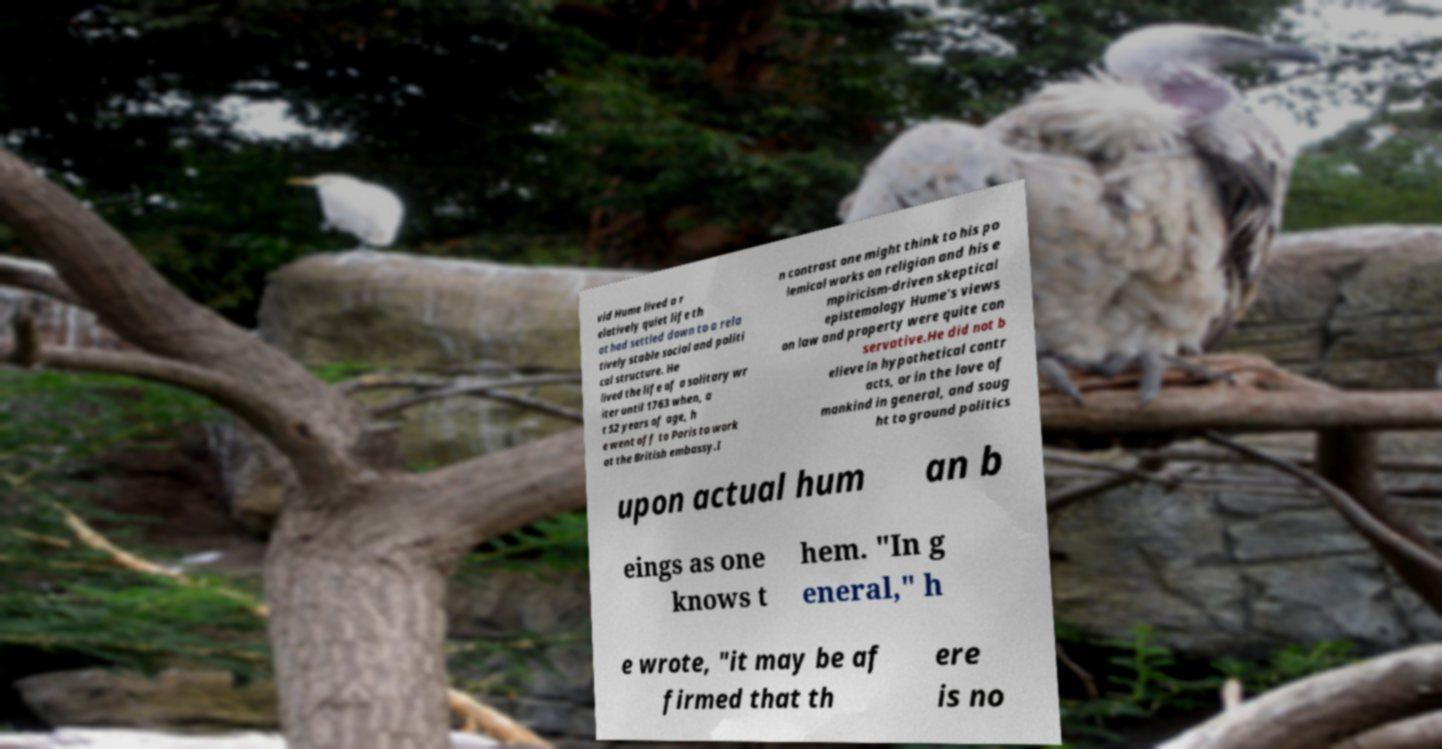Could you extract and type out the text from this image? vid Hume lived a r elatively quiet life th at had settled down to a rela tively stable social and politi cal structure. He lived the life of a solitary wr iter until 1763 when, a t 52 years of age, h e went off to Paris to work at the British embassy.I n contrast one might think to his po lemical works on religion and his e mpiricism-driven skeptical epistemology Hume's views on law and property were quite con servative.He did not b elieve in hypothetical contr acts, or in the love of mankind in general, and soug ht to ground politics upon actual hum an b eings as one knows t hem. "In g eneral," h e wrote, "it may be af firmed that th ere is no 